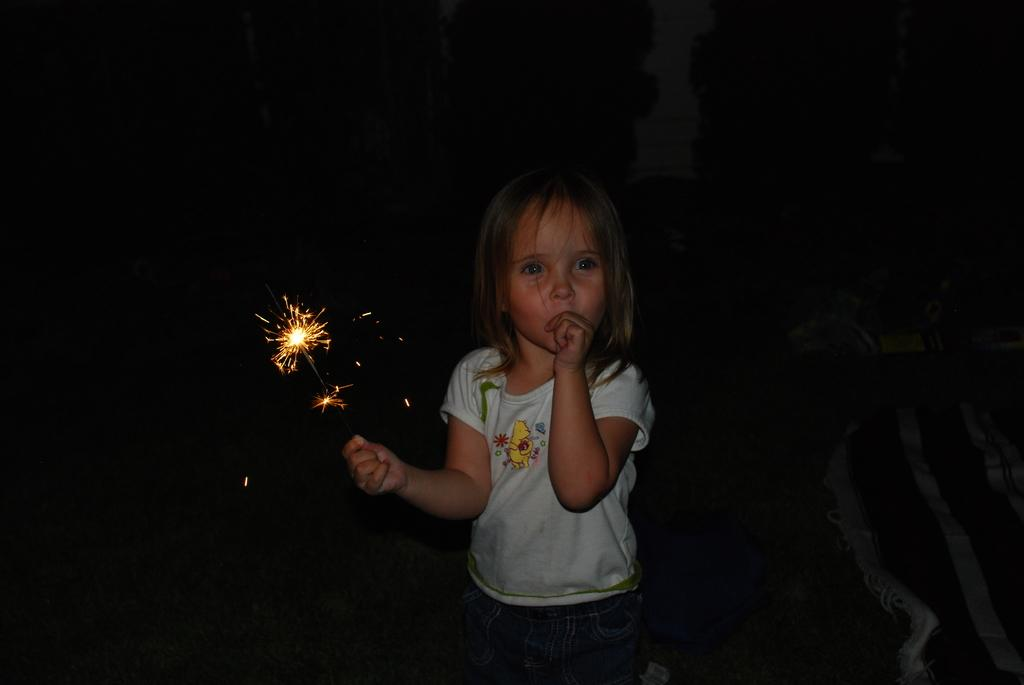Who is the main subject in the image? There is a girl in the image. What is the girl holding in her hand? The girl is holding a firecracker in her hand. What can be observed about the background of the image? The background of the image is dark. What type of rings can be seen on the girl's fingers in the image? There are no rings visible on the girl's fingers in the image. Is there a van parked in the background of the image? There is no van present in the image; the background is dark. 